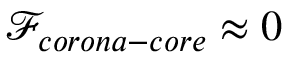Convert formula to latex. <formula><loc_0><loc_0><loc_500><loc_500>\mathcal { F } _ { c o r o n a - c o r e } \approx 0</formula> 